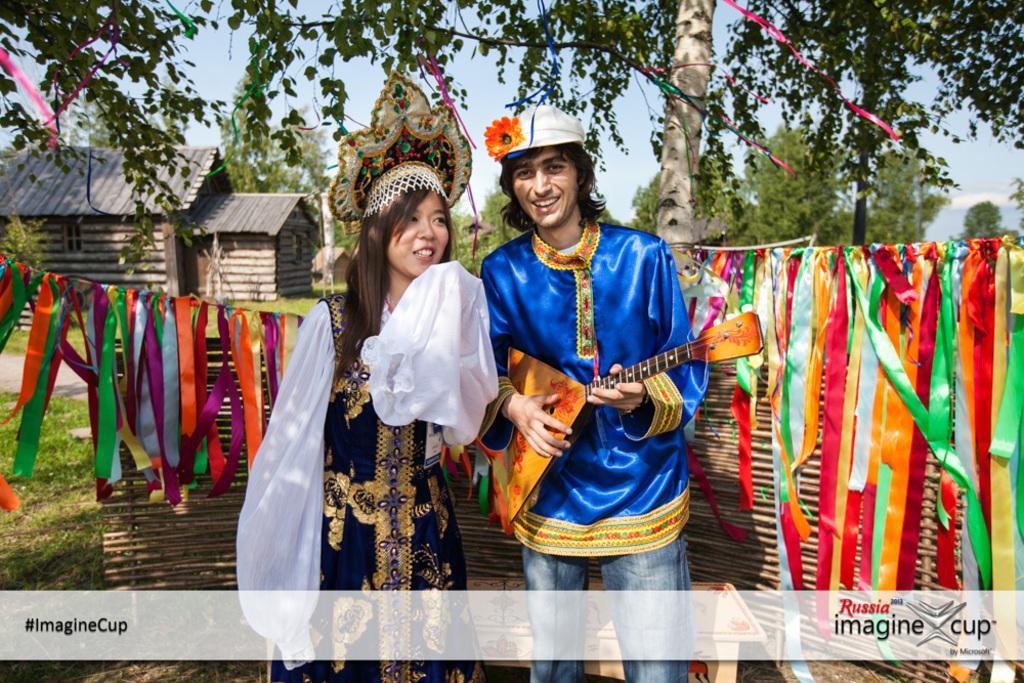Could you give a brief overview of what you see in this image? in this image there are two persons one is woman and another one is man they are standing on the floor in the middle and behind the persons some ribbons are hanging and on the left side small houses like huts and behind the persons and the background is greenery. 